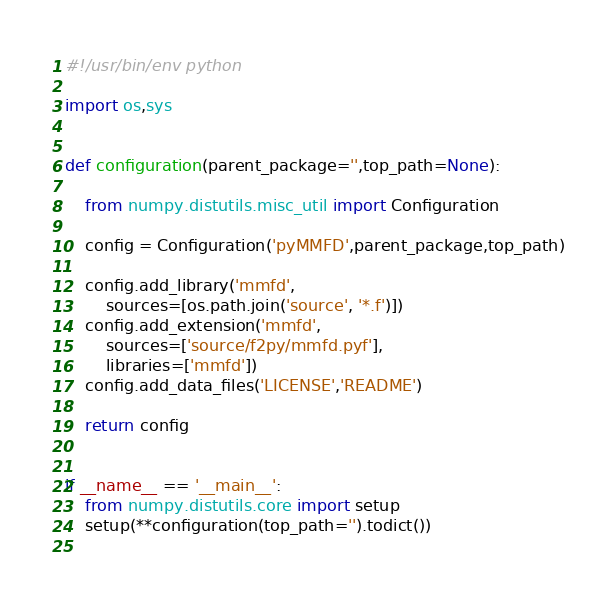<code> <loc_0><loc_0><loc_500><loc_500><_Python_>#!/usr/bin/env python

import os,sys


def configuration(parent_package='',top_path=None):
    
    from numpy.distutils.misc_util import Configuration
    
    config = Configuration('pyMMFD',parent_package,top_path)
    
    config.add_library('mmfd',
        sources=[os.path.join('source', '*.f')])
    config.add_extension('mmfd',
        sources=['source/f2py/mmfd.pyf'],
        libraries=['mmfd'])
    config.add_data_files('LICENSE','README')
    
    return config
    

if __name__ == '__main__':
    from numpy.distutils.core import setup
    setup(**configuration(top_path='').todict())
    
</code> 